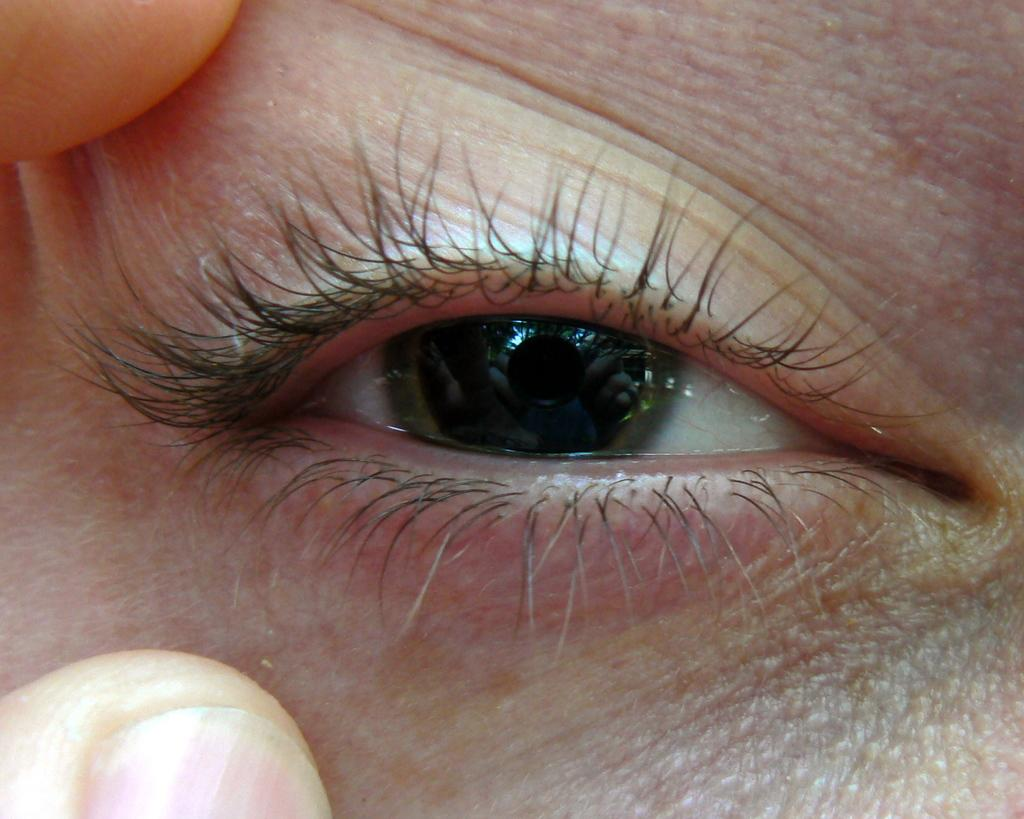What is the main subject of the image? The main subject of the image is an eye. Can you describe any other features in the image? The fingers of a person are truncated in the image. What type of toys can be seen in the image? There are no toys present in the image. Is there a hat visible in the image? There is no hat visible in the image. 